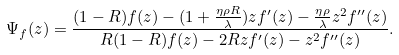Convert formula to latex. <formula><loc_0><loc_0><loc_500><loc_500>\Psi _ { f } ( z ) = \frac { ( 1 - R ) f ( z ) - ( 1 + \frac { \eta \rho R } { \lambda } ) z f ^ { \prime } ( z ) - \frac { \eta \rho } { \lambda } z ^ { 2 } f ^ { \prime \prime } ( z ) } { R ( 1 - R ) f ( z ) - 2 R z f ^ { \prime } ( z ) - z ^ { 2 } f ^ { \prime \prime } ( z ) } .</formula> 